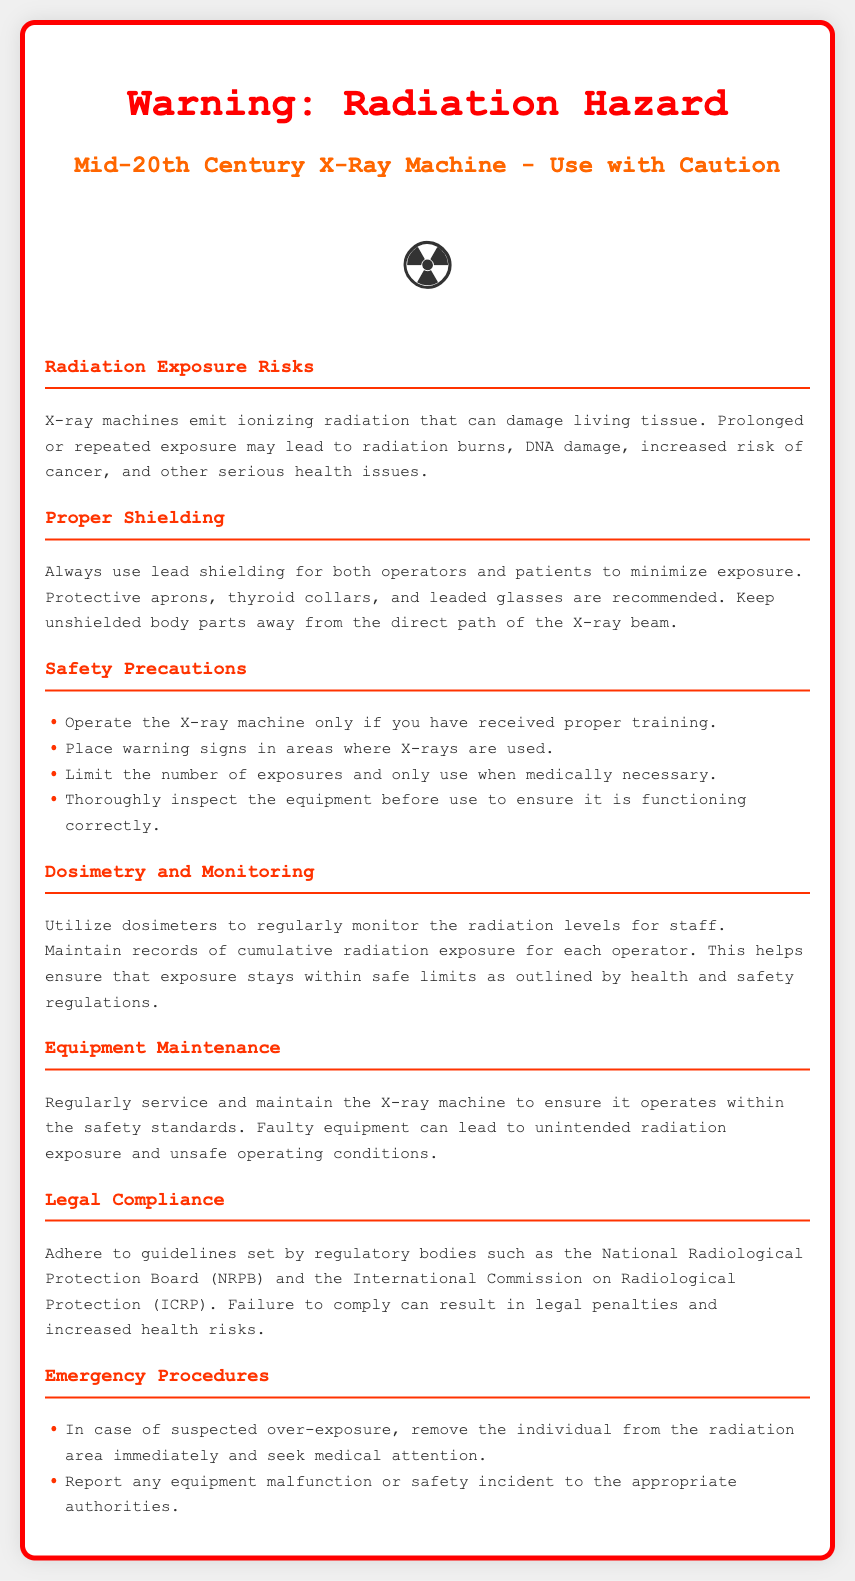What is the primary hazard associated with X-ray machines? The primary hazard mentioned in the document is the emission of ionizing radiation that can damage living tissue.
Answer: Ionizing radiation What items are recommended for proper shielding? The document lists protective aprons, thyroid collars, and leaded glasses as recommended for proper shielding.
Answer: Protective aprons, thyroid collars, and leaded glasses What should operators have received before operating the X-ray machine? The document states that operators should only operate the X-ray machine if they have received proper training.
Answer: Proper training According to the document, what is essential to monitor radiation levels for staff? The document mentions the use of dosimeters to regularly monitor radiation levels for staff.
Answer: Dosimeters What is the consequence of failing to comply with guidelines set by regulatory bodies? The document indicates that failing to comply can result in legal penalties and increased health risks.
Answer: Legal penalties What should be done in case of suspected over-exposure? The document states to remove the individual from the radiation area immediately and seek medical attention.
Answer: Seek medical attention What does the document advise regarding the inspection of the equipment? It advises to thoroughly inspect the equipment before use to ensure it is functioning correctly.
Answer: Inspect the equipment What type of radiation does the X-ray machine emit? The type of radiation emitted by the X-ray machine, as stated in the document, is ionizing radiation.
Answer: Ionizing radiation 